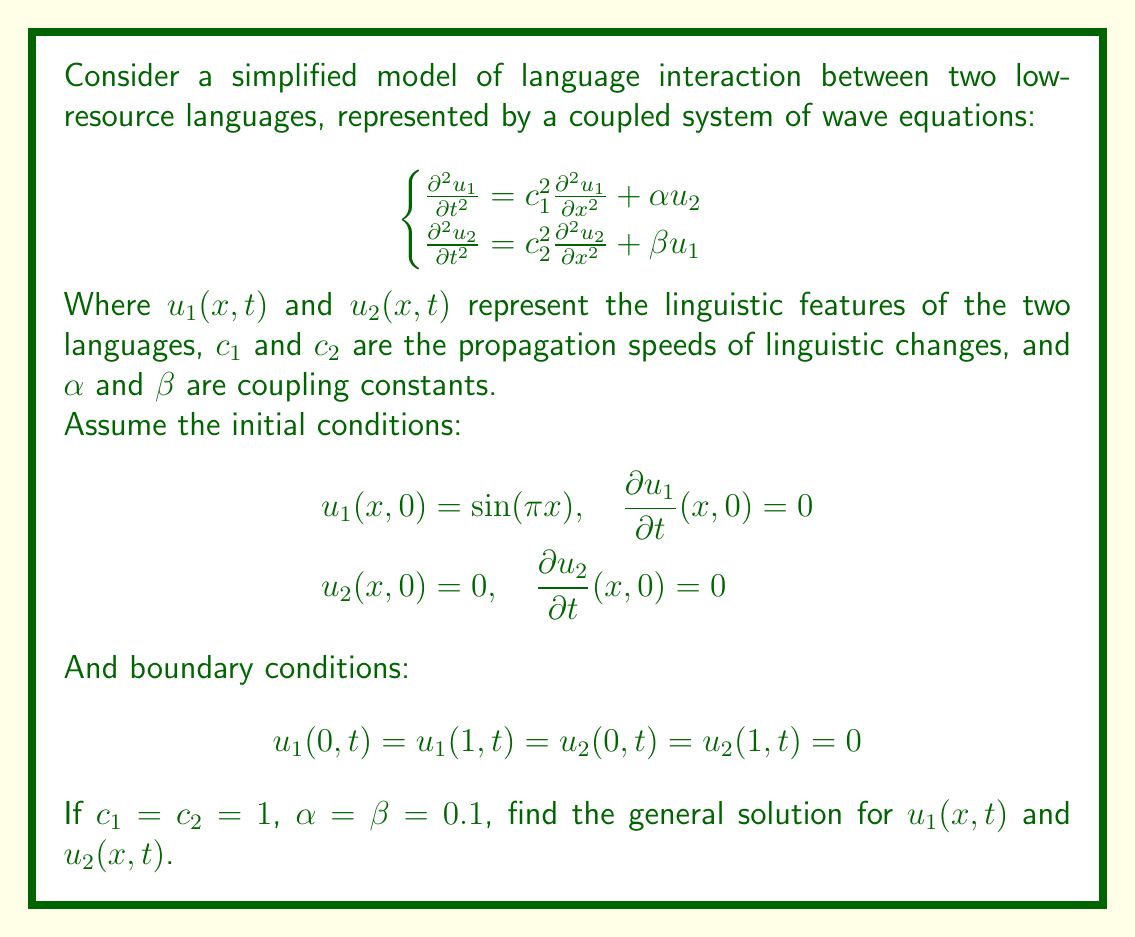Help me with this question. To solve this coupled system of wave equations, we'll follow these steps:

1) First, we assume solutions of the form:
   $$u_1(x,t) = X_1(x)T_1(t)$$
   $$u_2(x,t) = X_2(x)T_2(t)$$

2) Substituting these into the original equations:
   $$X_1T_1'' = X_1''T_1 + \alpha X_2T_2$$
   $$X_2T_2'' = X_2''T_2 + \beta X_1T_1$$

3) Separating variables:
   $$\frac{T_1''}{T_1} = \frac{X_1''}{X_1} + \alpha \frac{X_2T_2}{X_1T_1} = -\lambda^2$$
   $$\frac{T_2''}{T_2} = \frac{X_2''}{X_2} + \beta \frac{X_1T_1}{X_2T_2} = -\lambda^2$$

   Where $-\lambda^2$ is the separation constant.

4) This leads to the spatial equations:
   $$X_1'' + \lambda^2 X_1 = 0$$
   $$X_2'' + \lambda^2 X_2 = 0$$

   With solutions satisfying the boundary conditions:
   $$X_1(x) = A_1 \sin(n\pi x)$$
   $$X_2(x) = A_2 \sin(n\pi x)$$

   Where $n$ is a positive integer and $\lambda = n\pi$.

5) For the temporal part, we have:
   $$T_1'' + (n^2\pi^2 - \alpha \frac{A_2}{A_1})T_1 = 0$$
   $$T_2'' + (n^2\pi^2 - \beta \frac{A_1}{A_2})T_2 = 0$$

6) Let $\omega_1^2 = n^2\pi^2 - \alpha \frac{A_2}{A_1}$ and $\omega_2^2 = n^2\pi^2 - \beta \frac{A_1}{A_2}$. The solutions are:
   $$T_1(t) = B_1 \cos(\omega_1 t) + C_1 \sin(\omega_1 t)$$
   $$T_2(t) = B_2 \cos(\omega_2 t) + C_2 \sin(\omega_2 t)$$

7) Applying the initial conditions:
   For $u_1$: $A_1 = 1$, $B_1 = 1$, $C_1 = 0$
   For $u_2$: $A_2 = \frac{\alpha}{\omega_1^2 - \omega_2^2}$, $B_2 = 0$, $C_2 = -\frac{\alpha}{\omega_1(\omega_1^2 - \omega_2^2)}$

8) Therefore, the general solutions are:
   $$u_1(x,t) = \sin(\pi x) \cos(\omega_1 t)$$
   $$u_2(x,t) = \frac{\alpha}{\omega_1^2 - \omega_2^2} \sin(\pi x) [\cos(\omega_2 t) - \cos(\omega_1 t)]$$

   Where $\omega_1^2 = \pi^2 - 0.1\frac{A_2}{A_1}$ and $\omega_2^2 = \pi^2 - 0.1\frac{A_1}{A_2}$.
Answer: $$u_1(x,t) = \sin(\pi x) \cos(\omega_1 t)$$
$$u_2(x,t) = \frac{0.1}{\omega_1^2 - \omega_2^2} \sin(\pi x) [\cos(\omega_2 t) - \cos(\omega_1 t)]$$
Where $\omega_1^2 = \pi^2 - 0.1\frac{A_2}{A_1}$, $\omega_2^2 = \pi^2 - 0.1\frac{A_1}{A_2}$ 